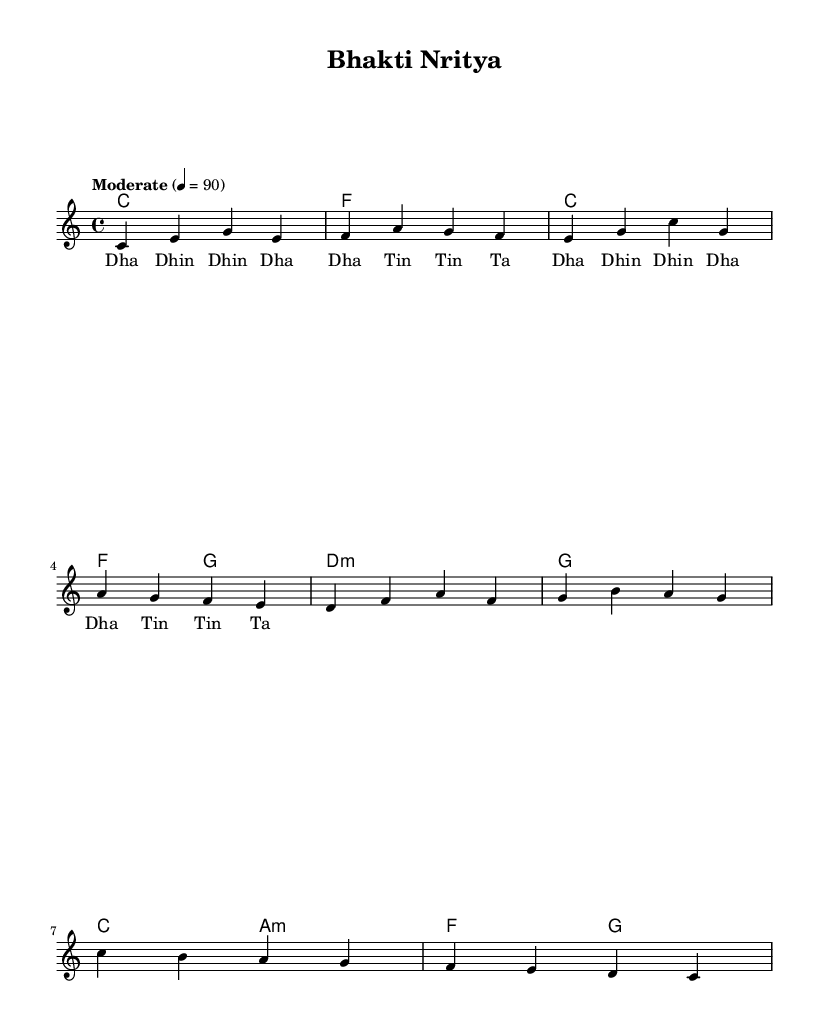What is the key signature of this music? The key signature is shown right after the clef and indicates C major, which has no sharps or flats.
Answer: C major What is the time signature of this piece? The time signature is displayed as a fraction at the beginning of the staff; here it is 4/4, meaning there are four beats in each measure.
Answer: 4/4 What is the tempo marking for this composition? The tempo marking indicates the speed of the music and is notated above the staff; in this piece it is "Moderate" at a speed of 90 beats per minute.
Answer: Moderate How many measures are in the melody? To find the number of measures, count the segments divided by vertical lines in the melody; there are 8 distinct measures.
Answer: 8 What is the first note of the melody? The first note in the melody is given at the start of measure one, which is a C note.
Answer: C How does the harmony change in the first four measures? The harmony progresses sequentially from C major to F major, returning to C major and concluding with F and G; this shows a clear pattern of moving between the tonic and subdominant.
Answer: C, F, C, F, G What is the rhythm pattern used in the lyrics? The lyrics demonstrate a repetitive rhythm pattern comprising "Dha Dhin Dhin Dha" and "Tin Tin Ta," which are traditional syllables used in Indian devotional music for expression.
Answer: Dha Dhin Dhin Dha, Tin Tin Ta 